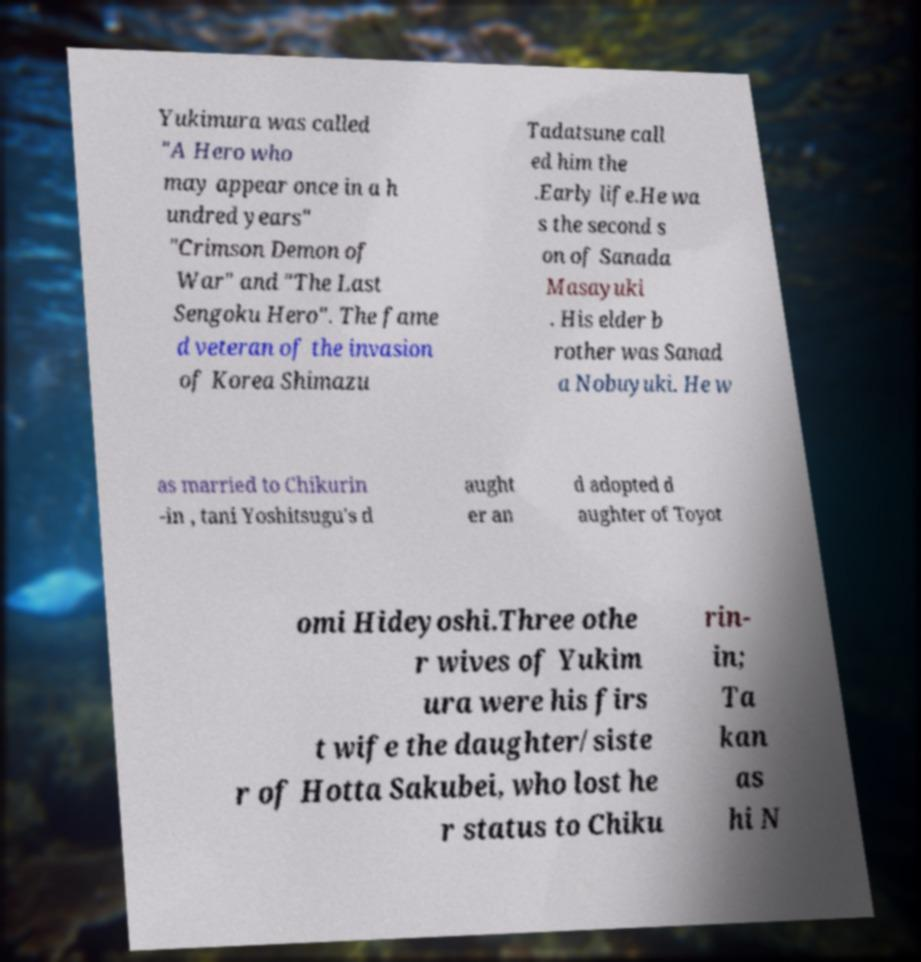Could you extract and type out the text from this image? Yukimura was called "A Hero who may appear once in a h undred years" "Crimson Demon of War" and "The Last Sengoku Hero". The fame d veteran of the invasion of Korea Shimazu Tadatsune call ed him the .Early life.He wa s the second s on of Sanada Masayuki . His elder b rother was Sanad a Nobuyuki. He w as married to Chikurin -in , tani Yoshitsugu's d aught er an d adopted d aughter of Toyot omi Hideyoshi.Three othe r wives of Yukim ura were his firs t wife the daughter/siste r of Hotta Sakubei, who lost he r status to Chiku rin- in; Ta kan as hi N 